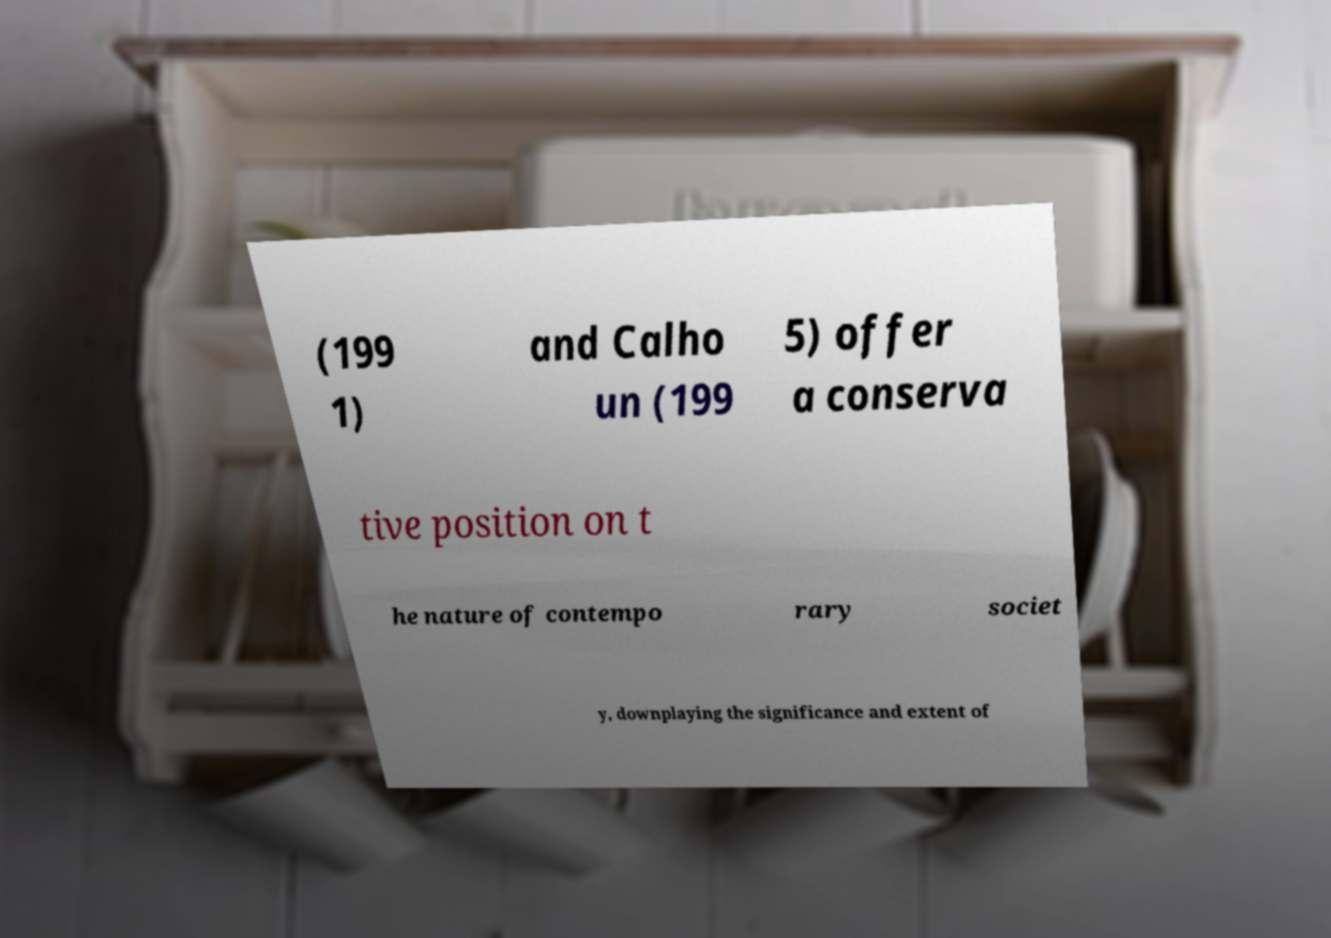Please identify and transcribe the text found in this image. (199 1) and Calho un (199 5) offer a conserva tive position on t he nature of contempo rary societ y, downplaying the significance and extent of 